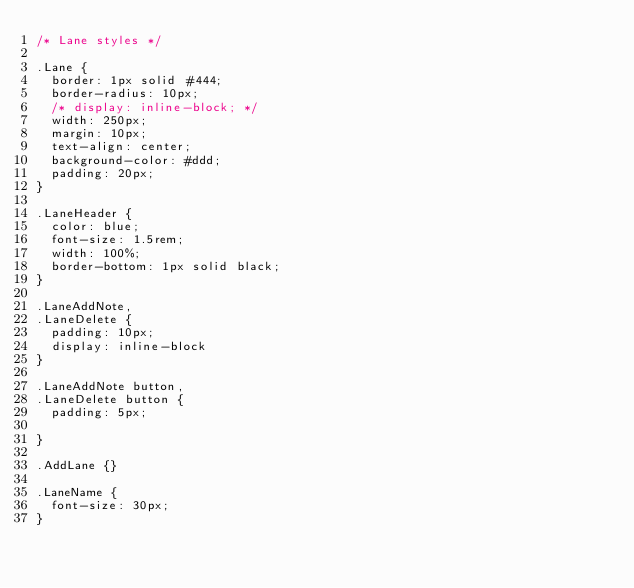Convert code to text. <code><loc_0><loc_0><loc_500><loc_500><_CSS_>/* Lane styles */

.Lane {
  border: 1px solid #444;
  border-radius: 10px;
  /* display: inline-block; */
  width: 250px;
  margin: 10px;
  text-align: center;
  background-color: #ddd;
  padding: 20px;
}

.LaneHeader {
  color: blue;
  font-size: 1.5rem;
  width: 100%;
  border-bottom: 1px solid black;
}

.LaneAddNote,
.LaneDelete {
  padding: 10px;
  display: inline-block
}

.LaneAddNote button,
.LaneDelete button {
  padding: 5px;

}

.AddLane {}

.LaneName {
  font-size: 30px;
}
</code> 